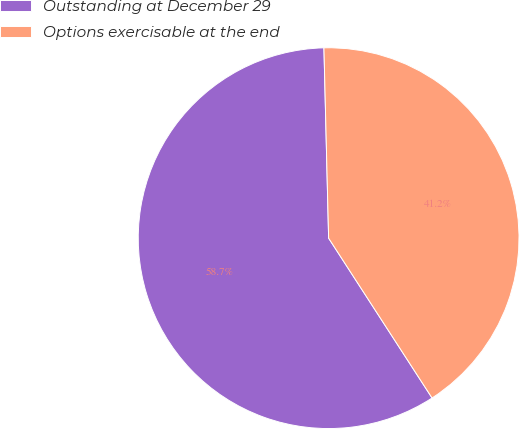Convert chart to OTSL. <chart><loc_0><loc_0><loc_500><loc_500><pie_chart><fcel>Outstanding at December 29<fcel>Options exercisable at the end<nl><fcel>58.75%<fcel>41.25%<nl></chart> 